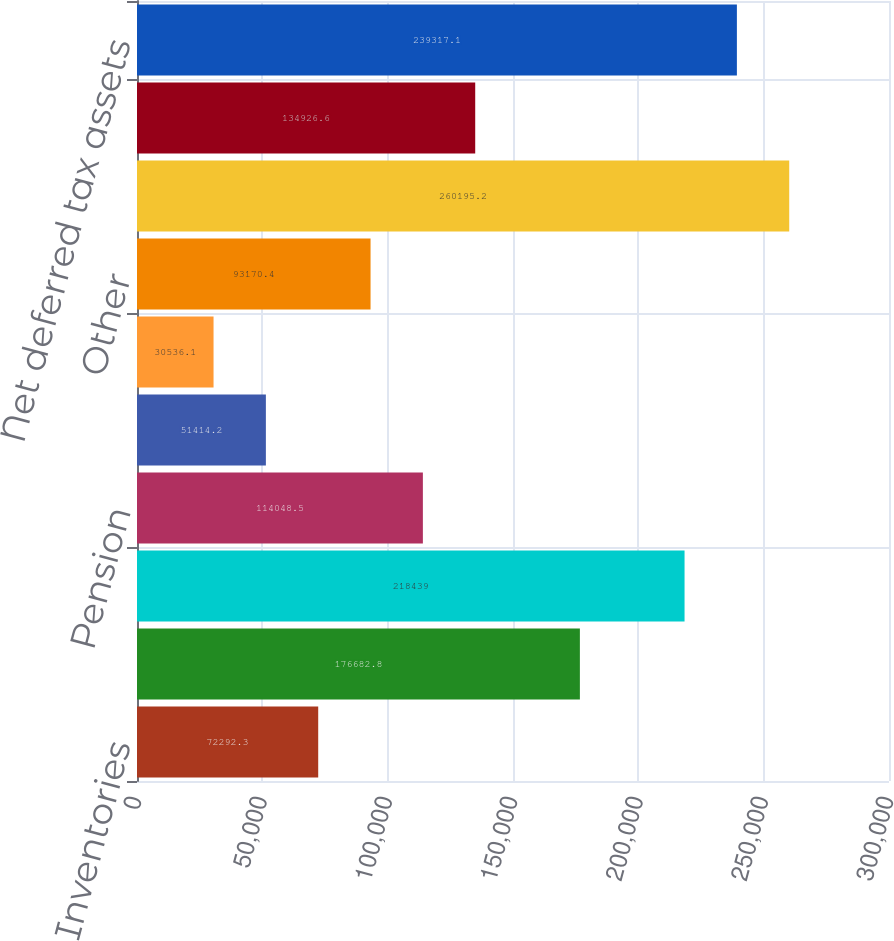Convert chart to OTSL. <chart><loc_0><loc_0><loc_500><loc_500><bar_chart><fcel>Inventories<fcel>Losses and tax credit<fcel>Operating expenses<fcel>Pension<fcel>Deferred compensation and<fcel>Postretirement benefits<fcel>Other<fcel>Gross deferred tax assets<fcel>Valuation allowance<fcel>Net deferred tax assets<nl><fcel>72292.3<fcel>176683<fcel>218439<fcel>114048<fcel>51414.2<fcel>30536.1<fcel>93170.4<fcel>260195<fcel>134927<fcel>239317<nl></chart> 